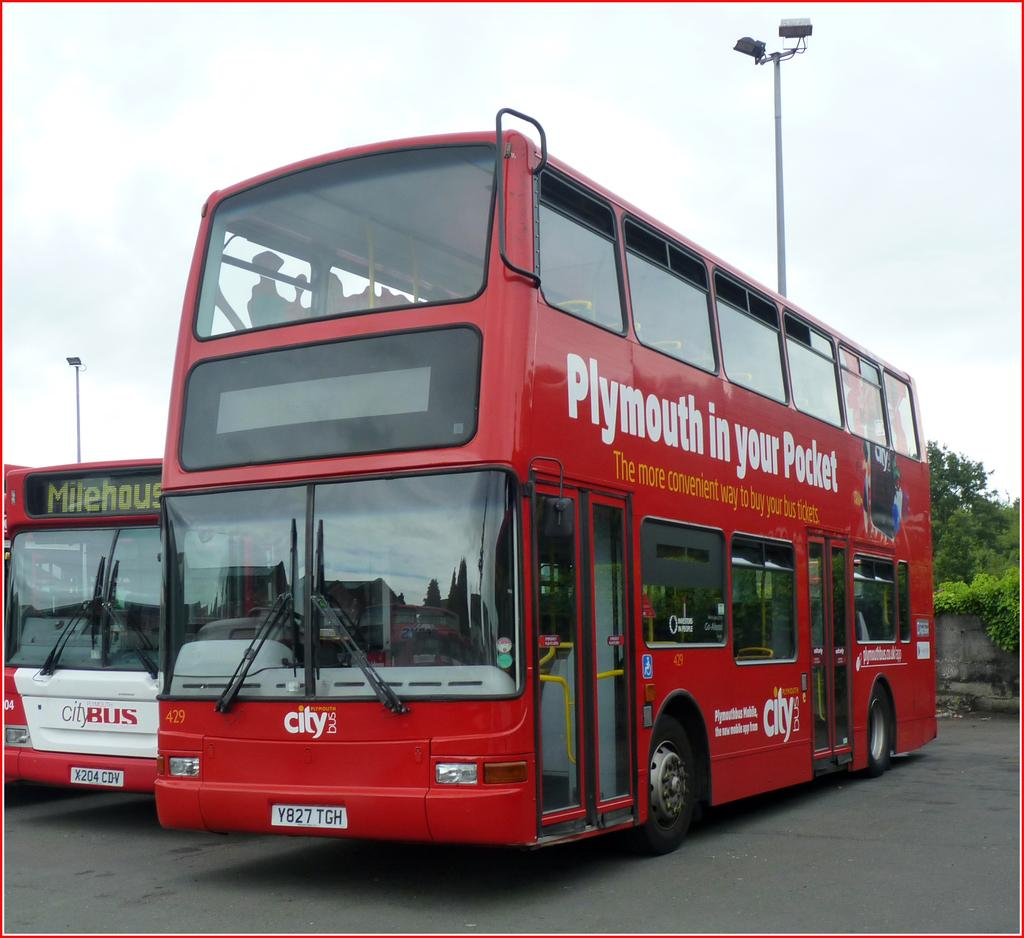<image>
Create a compact narrative representing the image presented. A city tour where you can access Plymouth in your Pocket. 